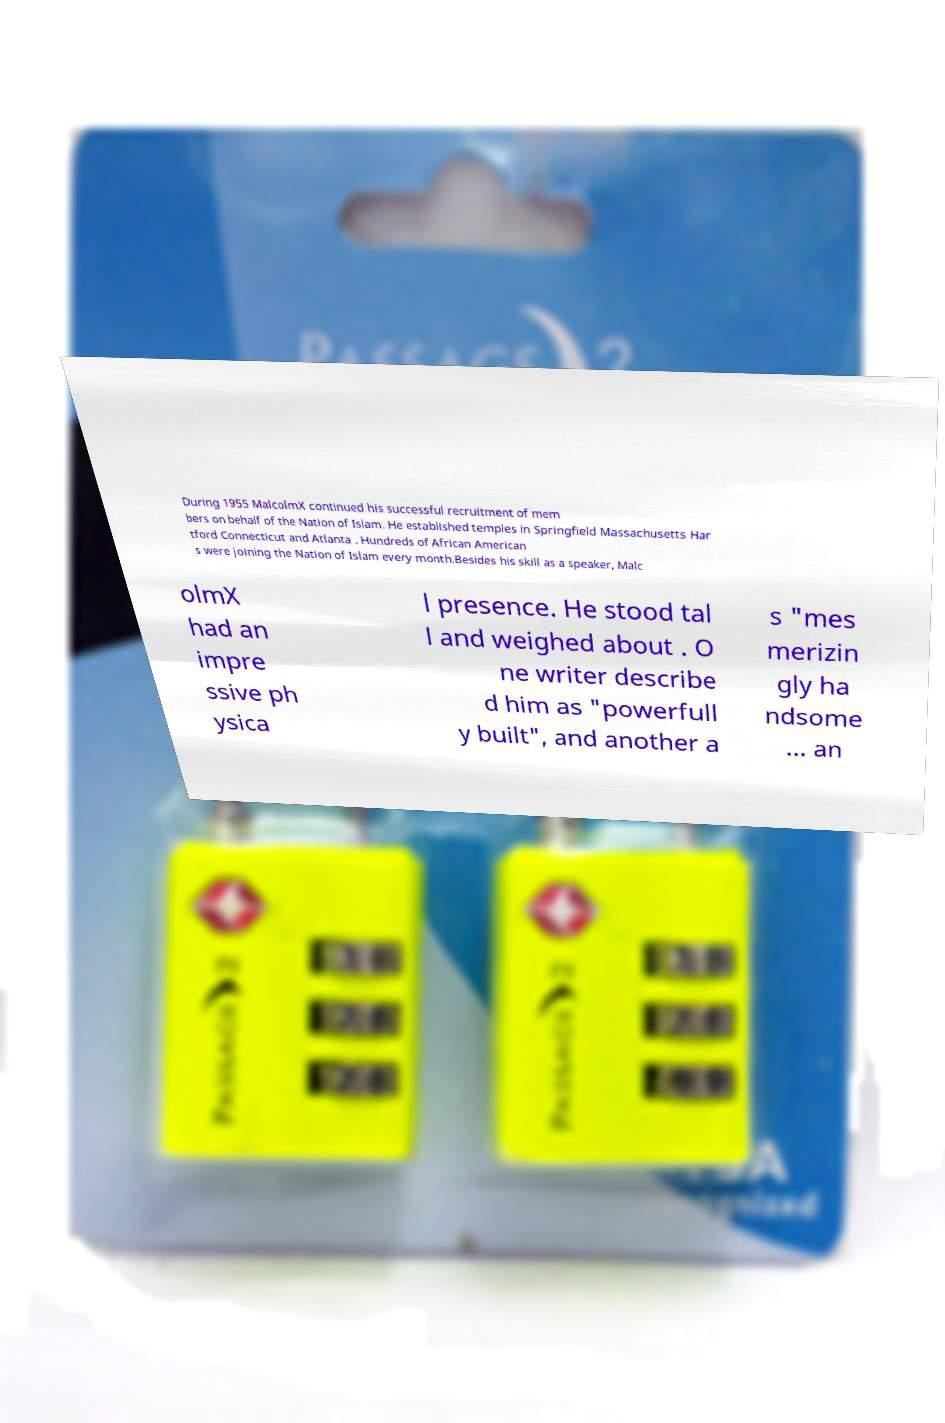I need the written content from this picture converted into text. Can you do that? During 1955 MalcolmX continued his successful recruitment of mem bers on behalf of the Nation of Islam. He established temples in Springfield Massachusetts Har tford Connecticut and Atlanta . Hundreds of African American s were joining the Nation of Islam every month.Besides his skill as a speaker, Malc olmX had an impre ssive ph ysica l presence. He stood tal l and weighed about . O ne writer describe d him as "powerfull y built", and another a s "mes merizin gly ha ndsome ... an 